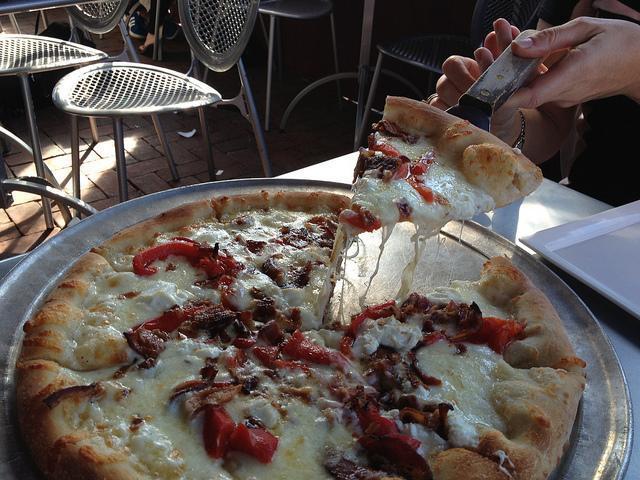How many chairs can be seen?
Give a very brief answer. 4. How many chairs can you see?
Give a very brief answer. 4. How many people are there?
Give a very brief answer. 1. How many sandwiches with tomato are there?
Give a very brief answer. 0. 